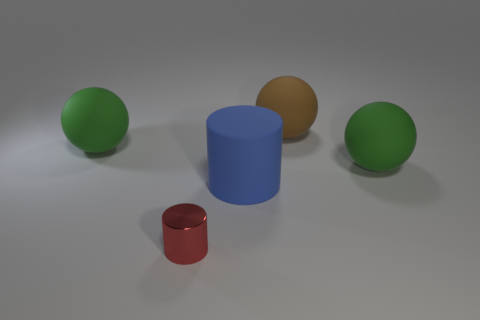Can you describe the objects in the image and their colors? Certainly! The image features two green spheres, a larger blue cylinder, a small shiny red cylinder, and a brown sphere. The objects are placed on a flat surface with a neutral grey background.  What could these objects represent metaphorically? Metaphorically speaking, these objects might represent diversity and individuality, with each shape and color symbolizing different characters or elements in a group or society. 